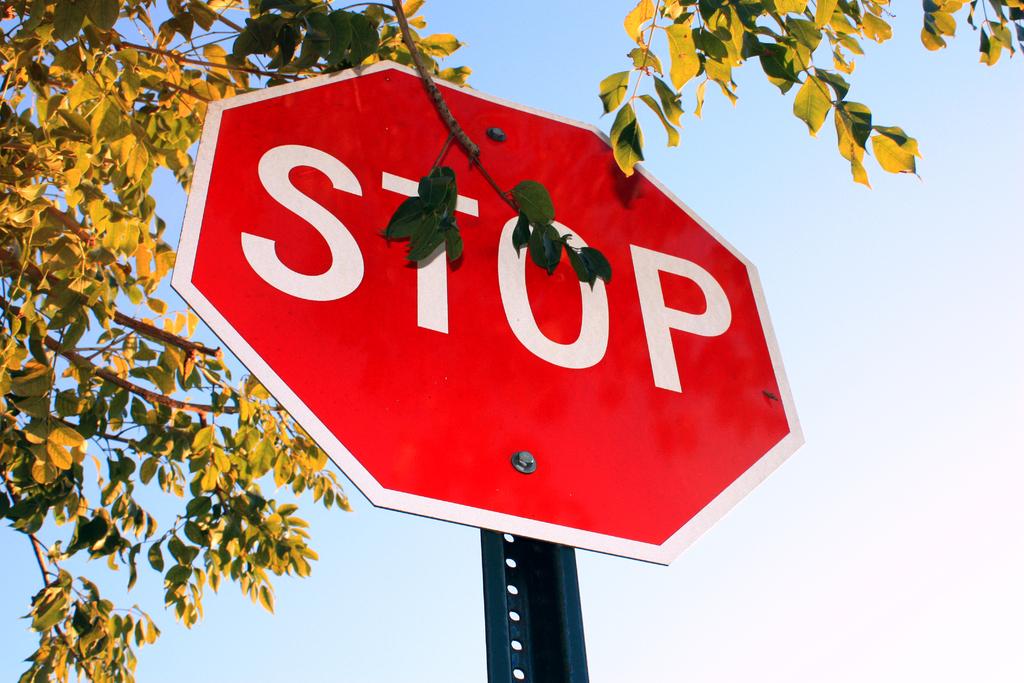What is this sign telling you to do?
Ensure brevity in your answer.  Stop. Is this a stop sign?
Ensure brevity in your answer.  Yes. 